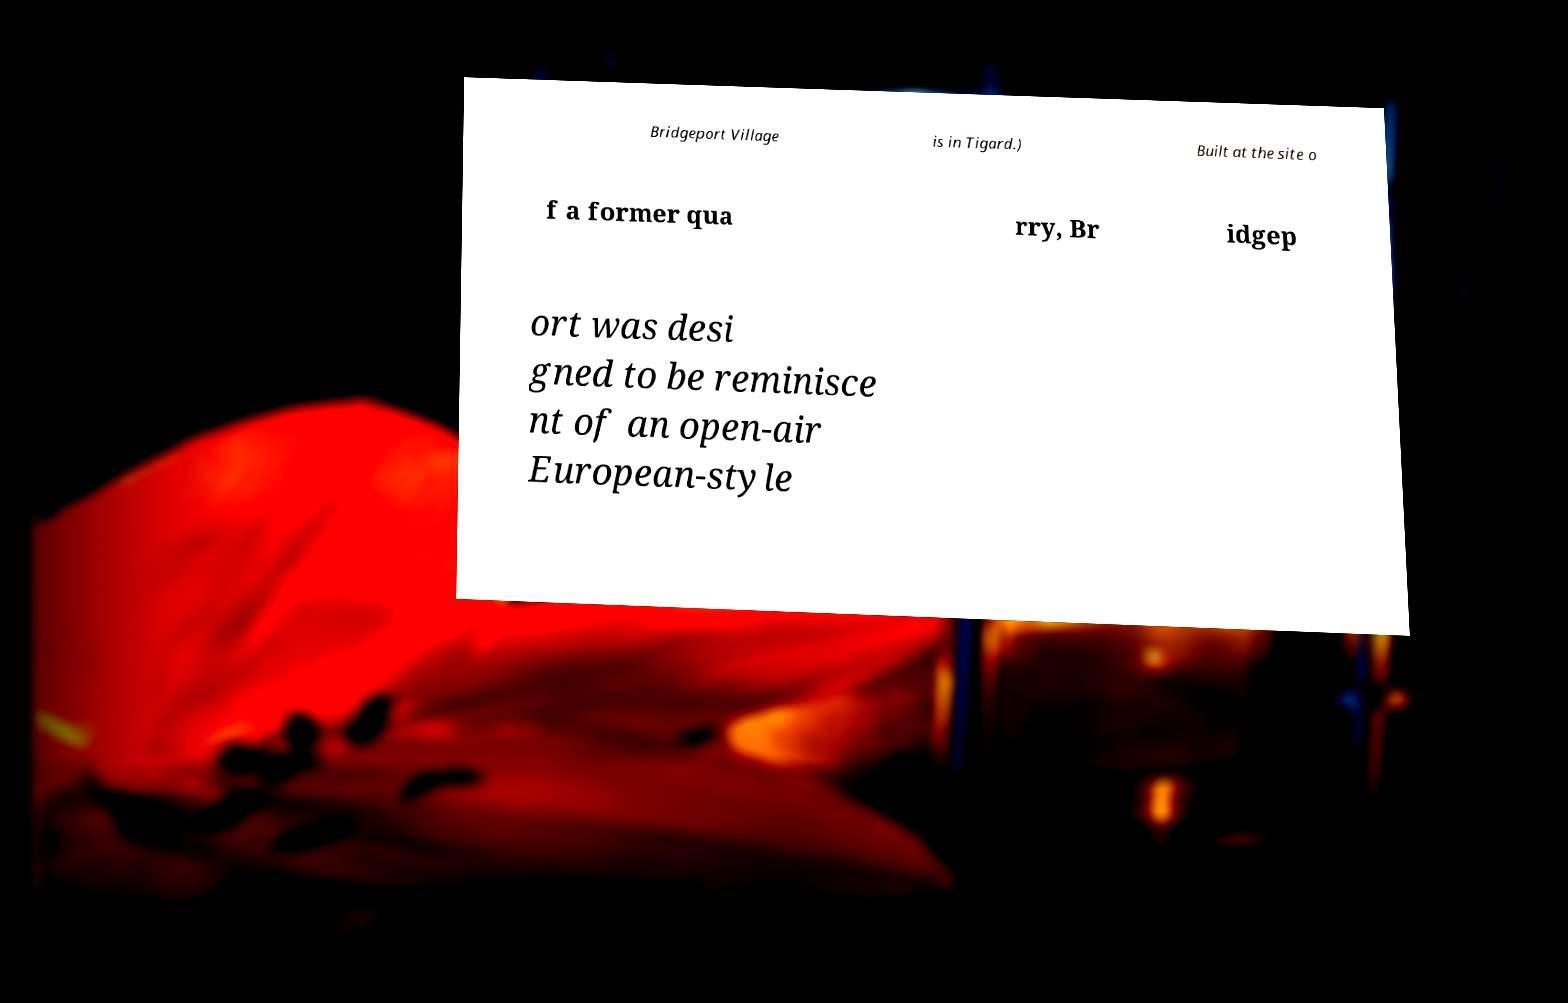There's text embedded in this image that I need extracted. Can you transcribe it verbatim? Bridgeport Village is in Tigard.) Built at the site o f a former qua rry, Br idgep ort was desi gned to be reminisce nt of an open-air European-style 